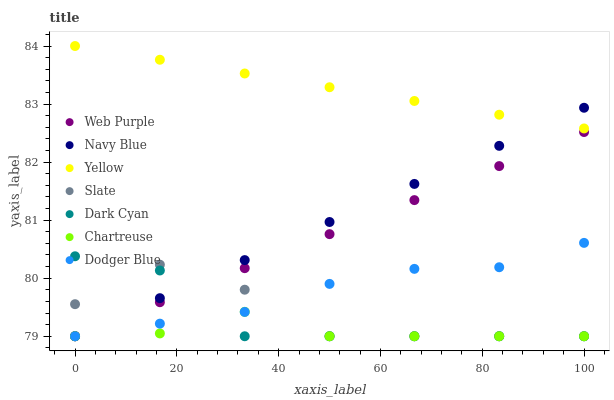Does Chartreuse have the minimum area under the curve?
Answer yes or no. Yes. Does Yellow have the maximum area under the curve?
Answer yes or no. Yes. Does Slate have the minimum area under the curve?
Answer yes or no. No. Does Slate have the maximum area under the curve?
Answer yes or no. No. Is Yellow the smoothest?
Answer yes or no. Yes. Is Slate the roughest?
Answer yes or no. Yes. Is Chartreuse the smoothest?
Answer yes or no. No. Is Chartreuse the roughest?
Answer yes or no. No. Does Navy Blue have the lowest value?
Answer yes or no. Yes. Does Yellow have the lowest value?
Answer yes or no. No. Does Yellow have the highest value?
Answer yes or no. Yes. Does Slate have the highest value?
Answer yes or no. No. Is Slate less than Yellow?
Answer yes or no. Yes. Is Yellow greater than Web Purple?
Answer yes or no. Yes. Does Chartreuse intersect Web Purple?
Answer yes or no. Yes. Is Chartreuse less than Web Purple?
Answer yes or no. No. Is Chartreuse greater than Web Purple?
Answer yes or no. No. Does Slate intersect Yellow?
Answer yes or no. No. 